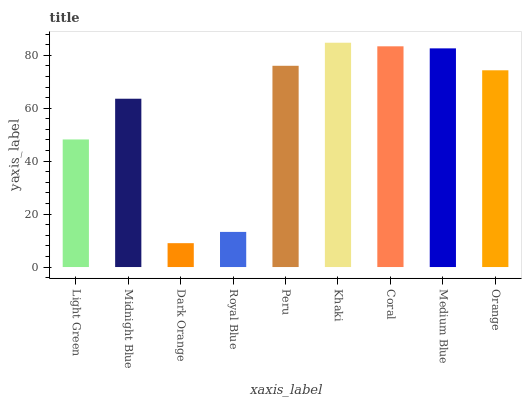Is Midnight Blue the minimum?
Answer yes or no. No. Is Midnight Blue the maximum?
Answer yes or no. No. Is Midnight Blue greater than Light Green?
Answer yes or no. Yes. Is Light Green less than Midnight Blue?
Answer yes or no. Yes. Is Light Green greater than Midnight Blue?
Answer yes or no. No. Is Midnight Blue less than Light Green?
Answer yes or no. No. Is Orange the high median?
Answer yes or no. Yes. Is Orange the low median?
Answer yes or no. Yes. Is Peru the high median?
Answer yes or no. No. Is Royal Blue the low median?
Answer yes or no. No. 